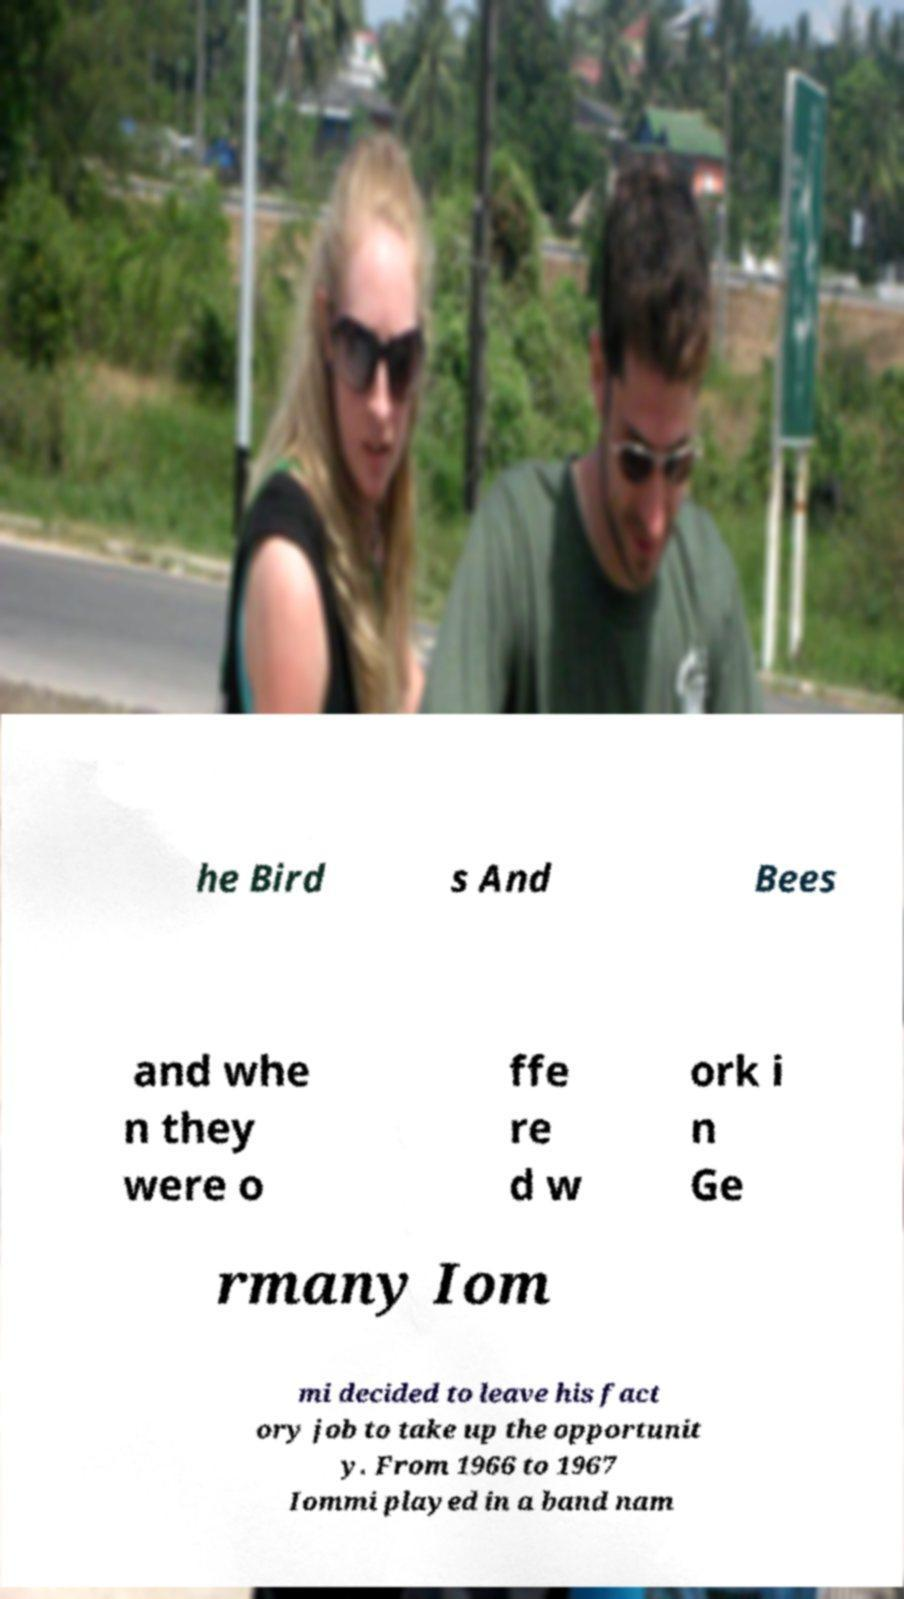Could you assist in decoding the text presented in this image and type it out clearly? he Bird s And Bees and whe n they were o ffe re d w ork i n Ge rmany Iom mi decided to leave his fact ory job to take up the opportunit y. From 1966 to 1967 Iommi played in a band nam 